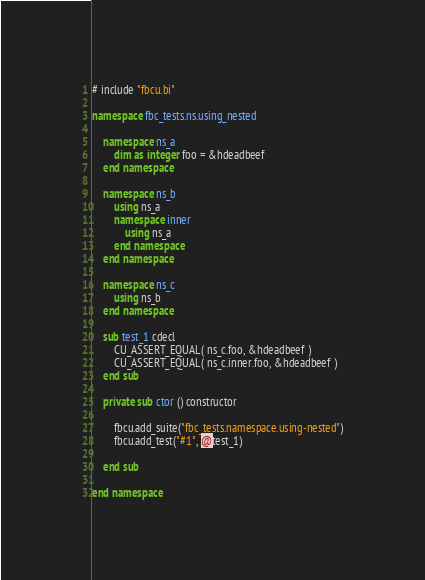Convert code to text. <code><loc_0><loc_0><loc_500><loc_500><_VisualBasic_># include "fbcu.bi"

namespace fbc_tests.ns.using_nested

	namespace ns_a
		dim as integer foo = &hdeadbeef
	end namespace
	
	namespace ns_b
		using ns_a
		namespace inner
			using ns_a
		end namespace
	end namespace
	
	namespace ns_c
		using ns_b
	end namespace
	
	sub test_1 cdecl	
		CU_ASSERT_EQUAL( ns_c.foo, &hdeadbeef )
		CU_ASSERT_EQUAL( ns_c.inner.foo, &hdeadbeef )
	end sub
	
	private sub ctor () constructor
	
		fbcu.add_suite("fbc_tests.namespace.using-nested")
		fbcu.add_test("#1", @test_1)
		
	end sub

end namespace		</code> 